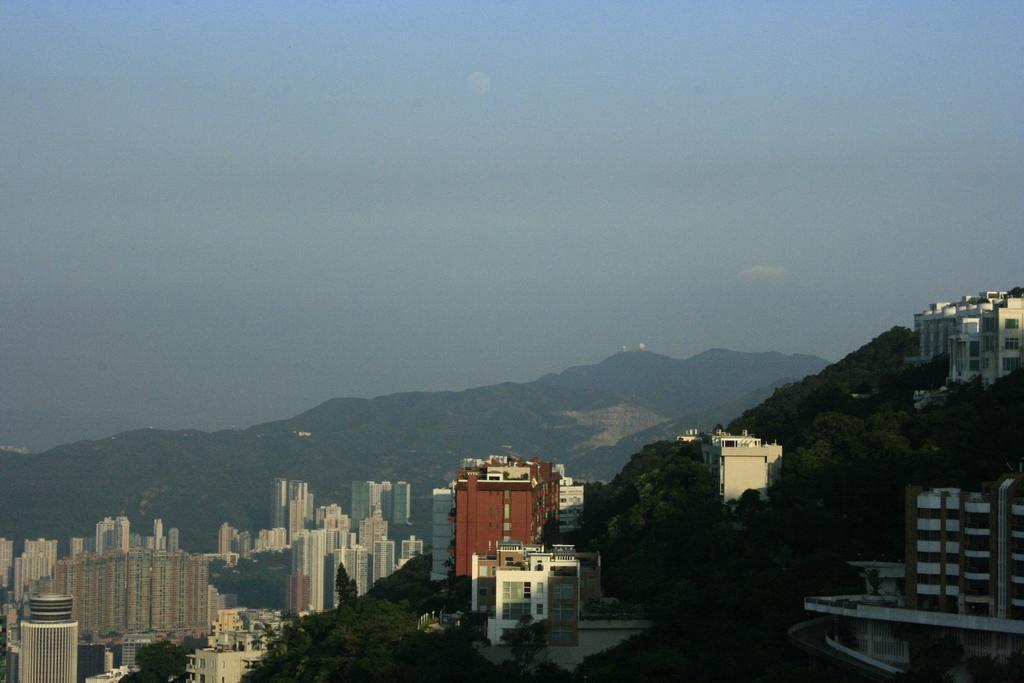In one or two sentences, can you explain what this image depicts? At the down there are buildings, in the middle there are trees. At the top it is the sky. 